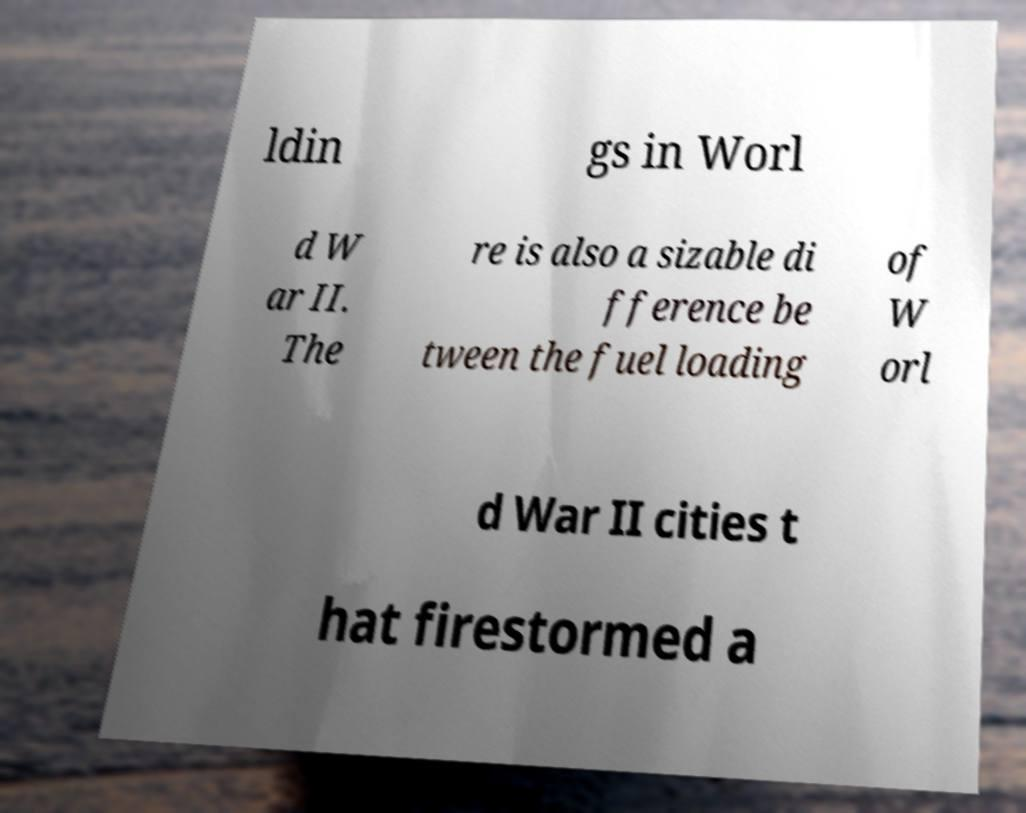Could you extract and type out the text from this image? ldin gs in Worl d W ar II. The re is also a sizable di fference be tween the fuel loading of W orl d War II cities t hat firestormed a 